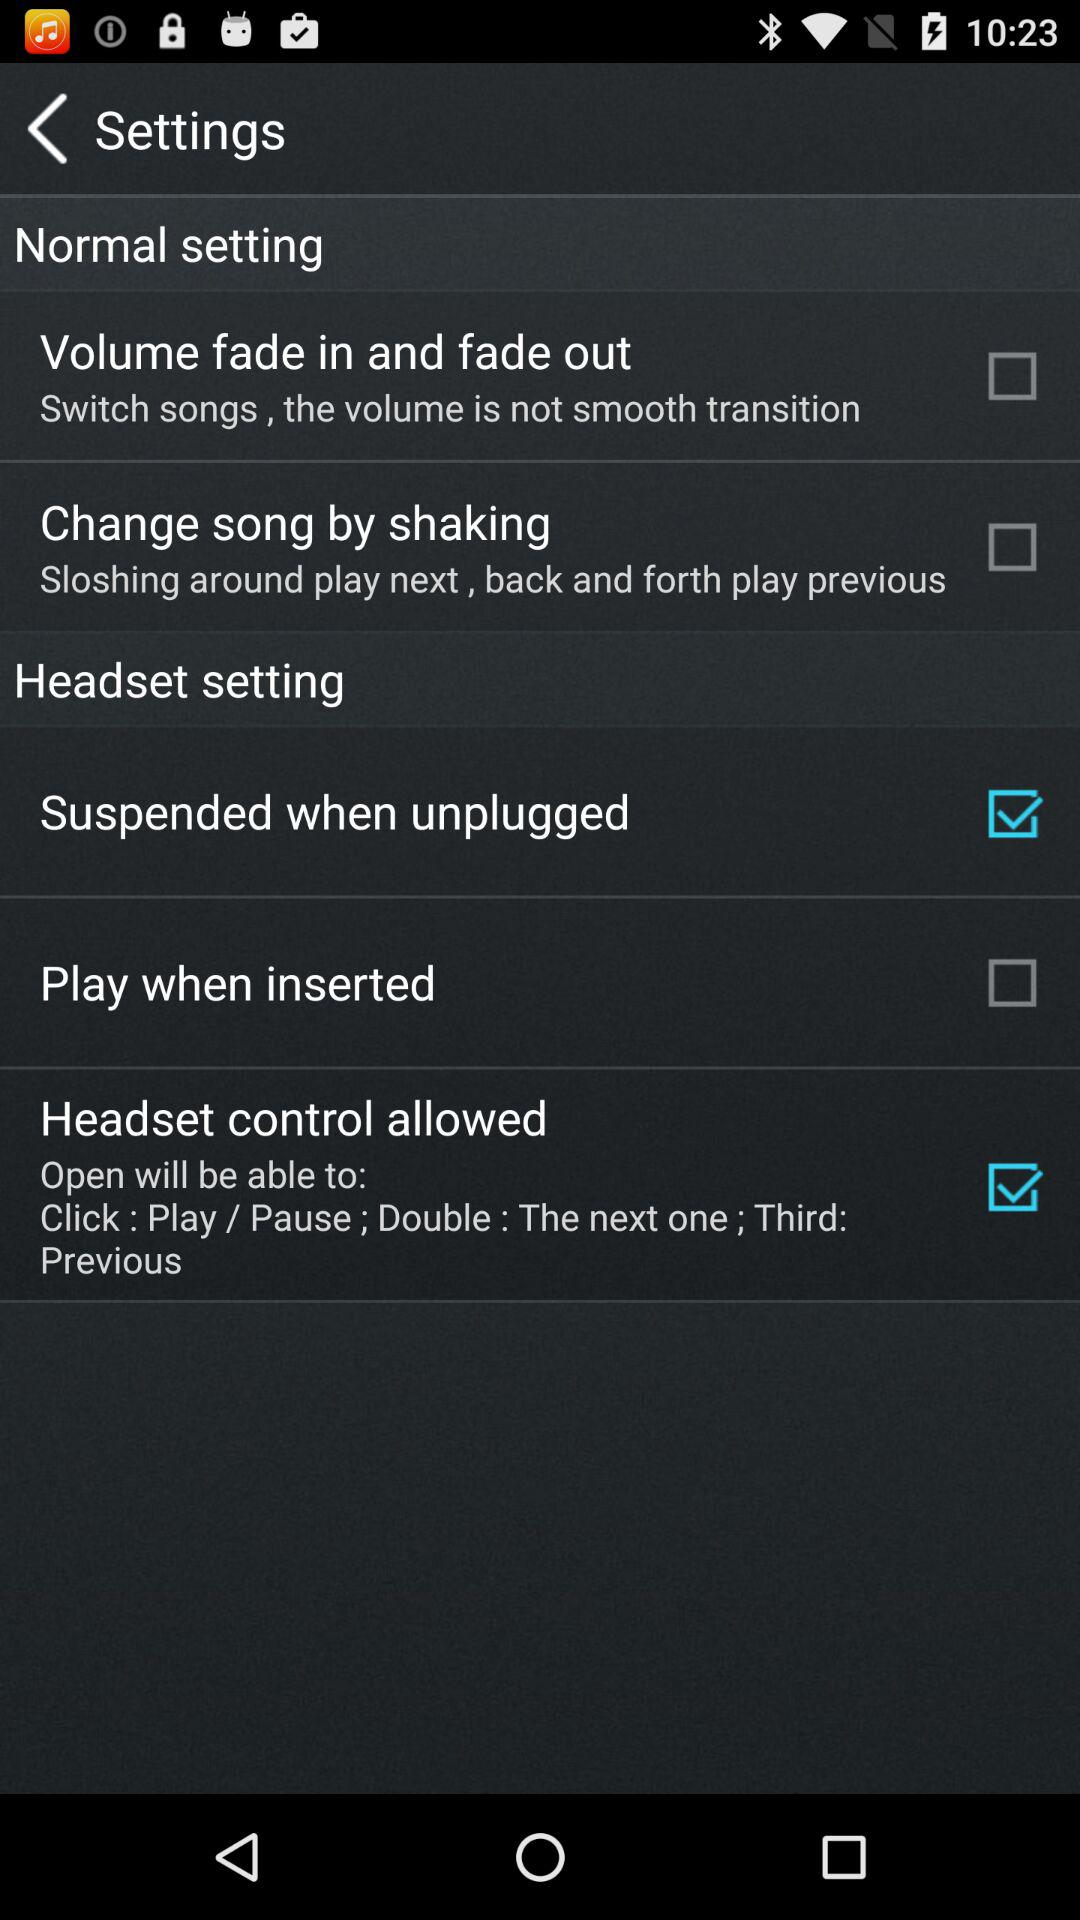What's the status of "Headset control allowed"? The status is on. 